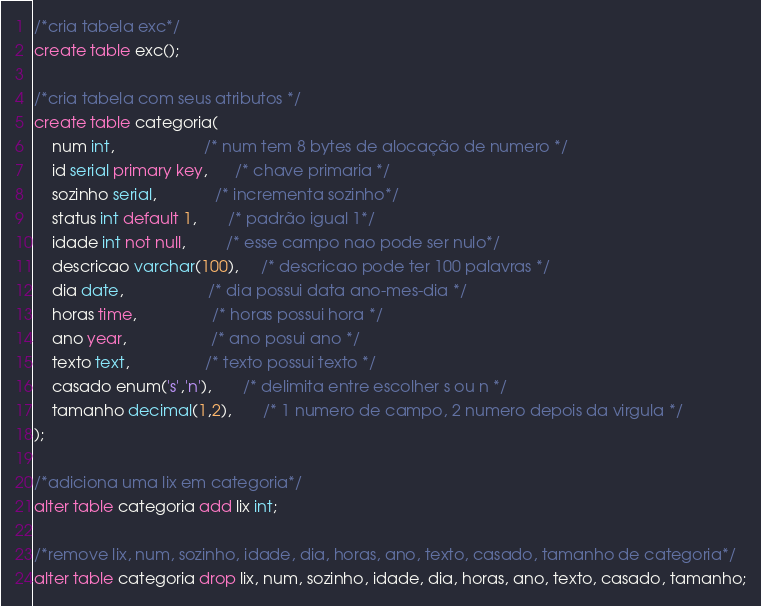<code> <loc_0><loc_0><loc_500><loc_500><_SQL_>/*cria tabela exc*/
create table exc();

/*cria tabela com seus atributos */
create table categoria(
    num int,                    /* num tem 8 bytes de alocação de numero */
    id serial primary key,      /* chave primaria */
    sozinho serial,             /* incrementa sozinho*/
    status int default 1,       /* padrão igual 1*/
    idade int not null,         /* esse campo nao pode ser nulo*/
    descricao varchar(100),     /* descricao pode ter 100 palavras */ 
    dia date,                   /* dia possui data ano-mes-dia */ 
    horas time,                 /* horas possui hora */ 
    ano year,                   /* ano posui ano */ 
    texto text,                 /* texto possui texto */ 
    casado enum('s','n'),       /* delimita entre escolher s ou n */  
    tamanho decimal(1,2),       /* 1 numero de campo, 2 numero depois da virgula */ 
);

/*adiciona uma lix em categoria*/
alter table categoria add lix int; 

/*remove lix, num, sozinho, idade, dia, horas, ano, texto, casado, tamanho de categoria*/
alter table categoria drop lix, num, sozinho, idade, dia, horas, ano, texto, casado, tamanho;
</code> 